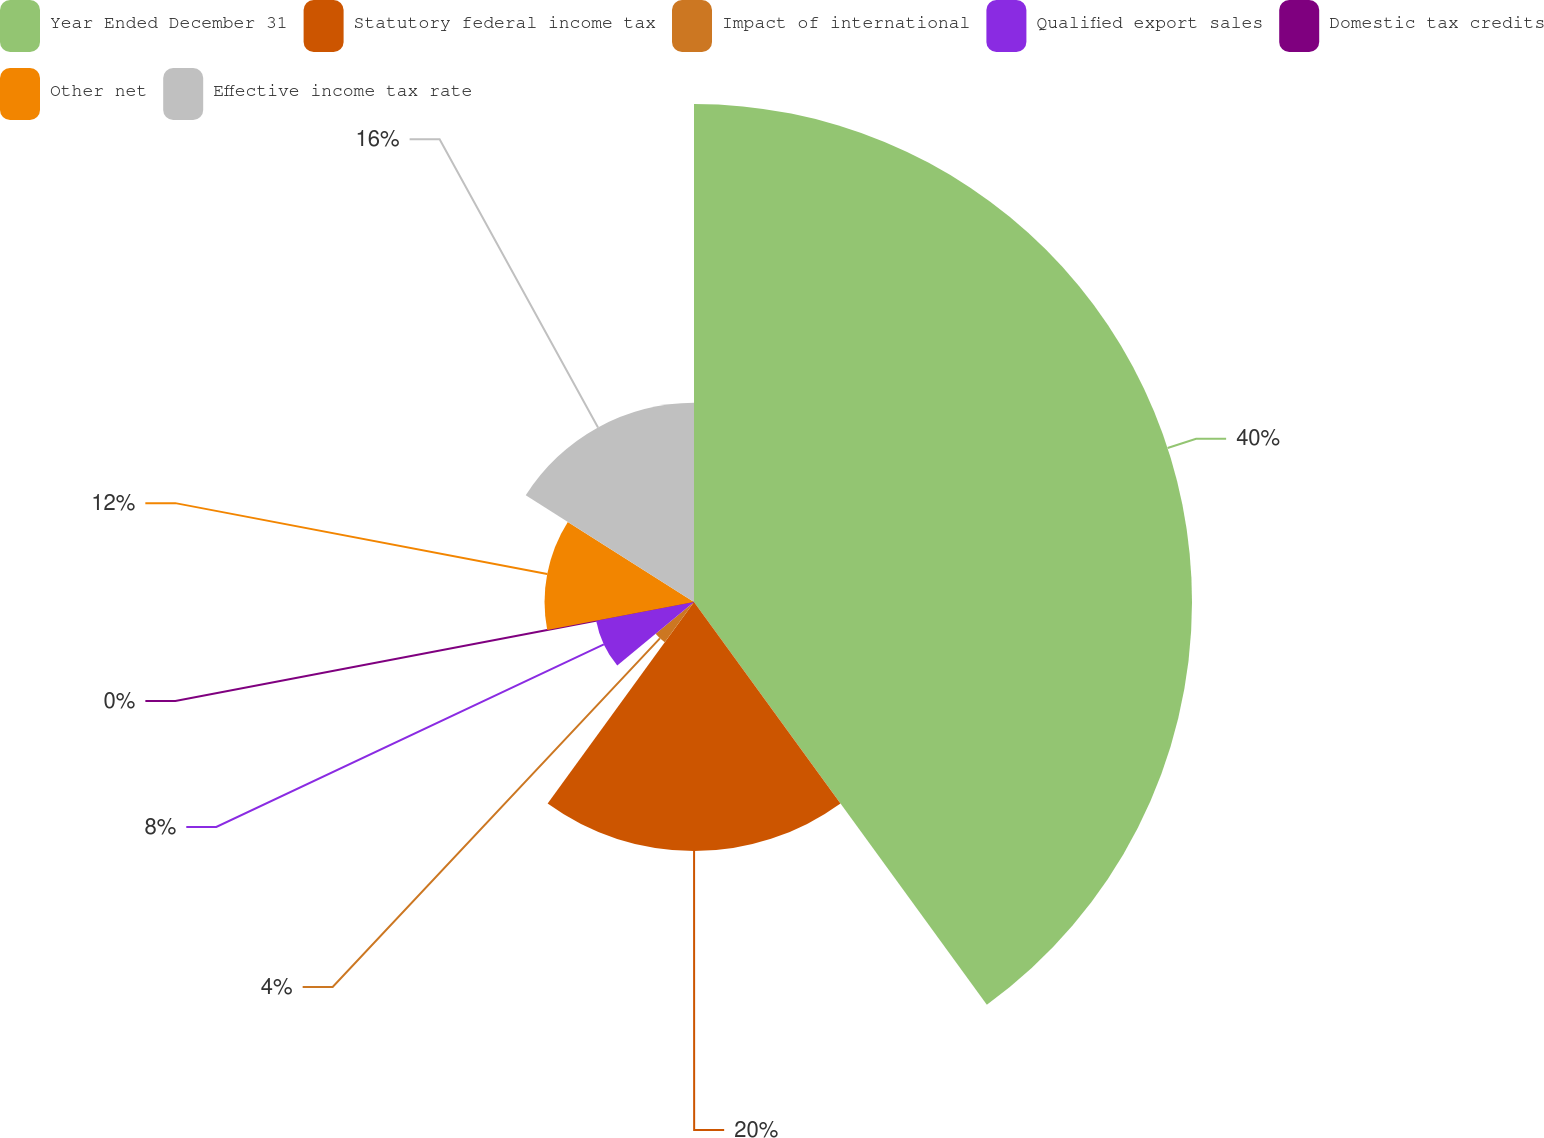<chart> <loc_0><loc_0><loc_500><loc_500><pie_chart><fcel>Year Ended December 31<fcel>Statutory federal income tax<fcel>Impact of international<fcel>Qualified export sales<fcel>Domestic tax credits<fcel>Other net<fcel>Effective income tax rate<nl><fcel>39.99%<fcel>20.0%<fcel>4.0%<fcel>8.0%<fcel>0.0%<fcel>12.0%<fcel>16.0%<nl></chart> 